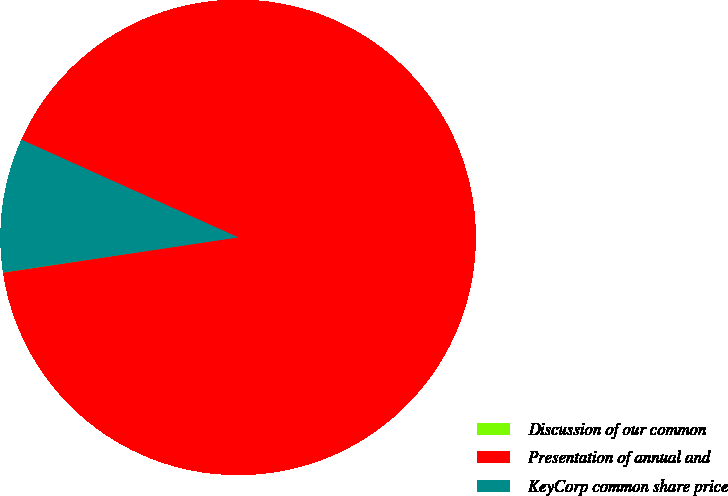Convert chart. <chart><loc_0><loc_0><loc_500><loc_500><pie_chart><fcel>Discussion of our common<fcel>Presentation of annual and<fcel>KeyCorp common share price<nl><fcel>0.02%<fcel>90.88%<fcel>9.1%<nl></chart> 